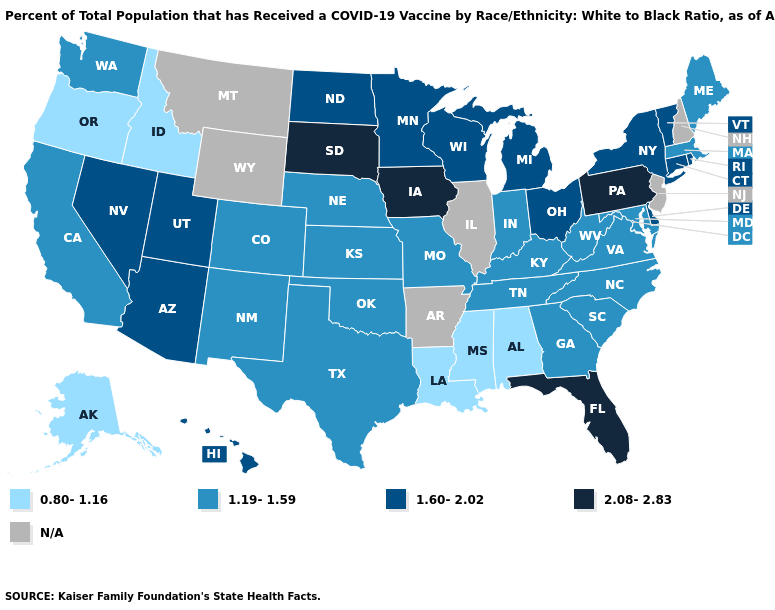Is the legend a continuous bar?
Keep it brief. No. What is the value of South Dakota?
Be succinct. 2.08-2.83. Among the states that border Utah , which have the highest value?
Concise answer only. Arizona, Nevada. Name the states that have a value in the range N/A?
Keep it brief. Arkansas, Illinois, Montana, New Hampshire, New Jersey, Wyoming. What is the value of New Jersey?
Quick response, please. N/A. What is the highest value in the South ?
Answer briefly. 2.08-2.83. Name the states that have a value in the range 1.19-1.59?
Quick response, please. California, Colorado, Georgia, Indiana, Kansas, Kentucky, Maine, Maryland, Massachusetts, Missouri, Nebraska, New Mexico, North Carolina, Oklahoma, South Carolina, Tennessee, Texas, Virginia, Washington, West Virginia. What is the value of Idaho?
Answer briefly. 0.80-1.16. Which states have the highest value in the USA?
Give a very brief answer. Florida, Iowa, Pennsylvania, South Dakota. Name the states that have a value in the range 2.08-2.83?
Keep it brief. Florida, Iowa, Pennsylvania, South Dakota. What is the highest value in states that border Connecticut?
Write a very short answer. 1.60-2.02. Does Arizona have the highest value in the West?
Be succinct. Yes. What is the highest value in states that border Arizona?
Short answer required. 1.60-2.02. What is the value of California?
Give a very brief answer. 1.19-1.59. Does Nevada have the highest value in the West?
Answer briefly. Yes. 